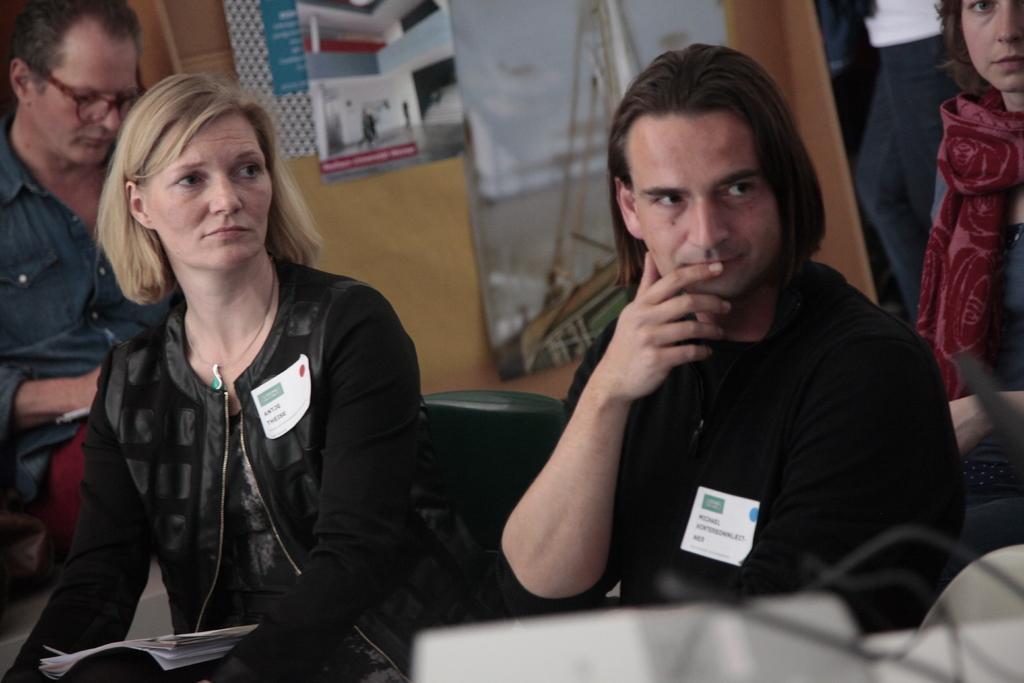Describe this image in one or two sentences. In this image we can see people sitting. In the background there are boards placed on the wall. 